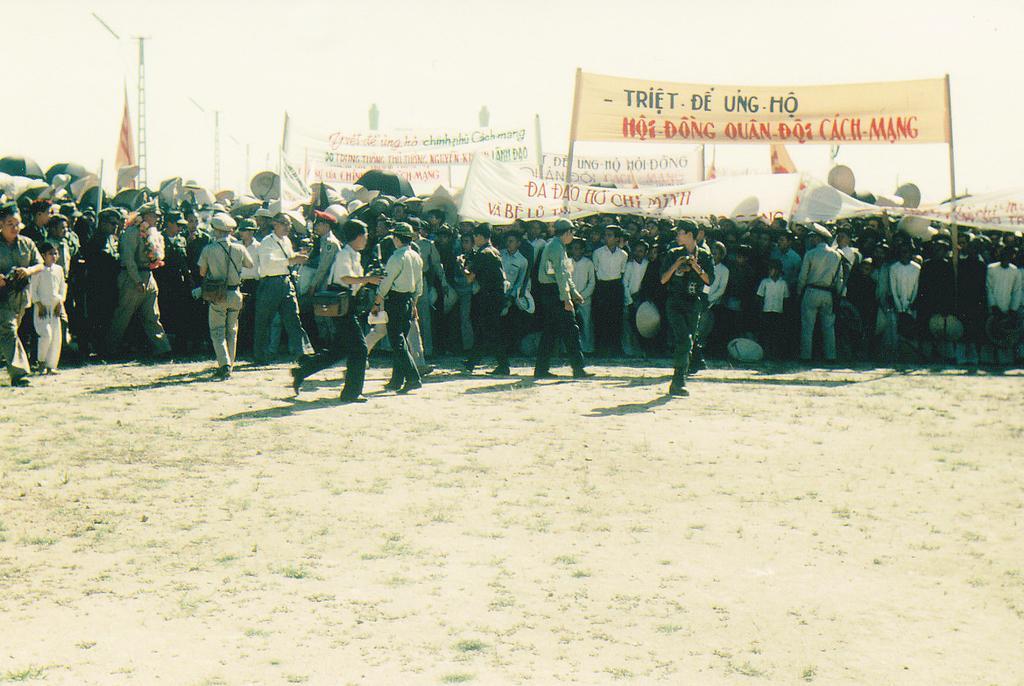In one or two sentences, can you explain what this image depicts? In this image I can see an open ground and on it I can see number of people are standing. I can see few people are wearing hats, few people are carrying bags, few people holding hats and few people holding cameras. On the left side of the image I can see one person is wearing a garland of flowers. On the top side of the image I can see the wall, few flags, few banners and on these banners I can see something is written. 